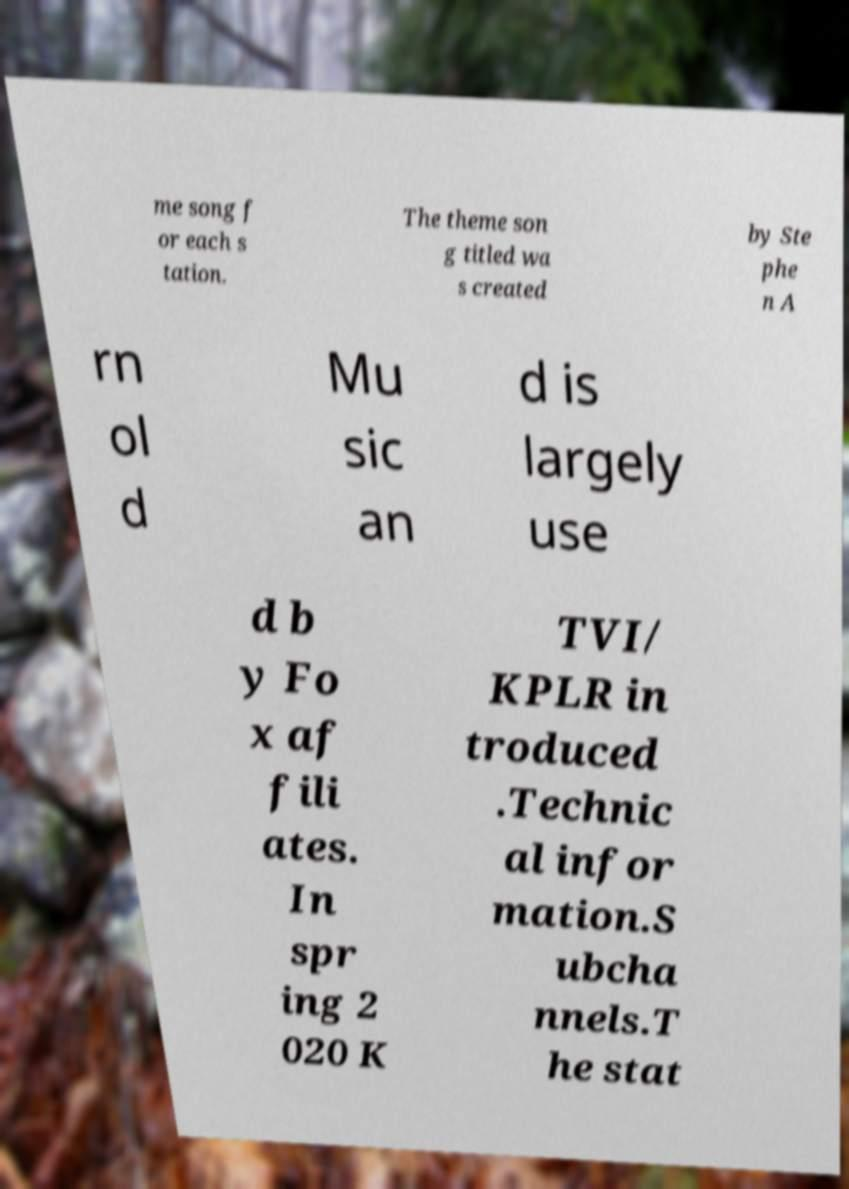Could you assist in decoding the text presented in this image and type it out clearly? me song f or each s tation. The theme son g titled wa s created by Ste phe n A rn ol d Mu sic an d is largely use d b y Fo x af fili ates. In spr ing 2 020 K TVI/ KPLR in troduced .Technic al infor mation.S ubcha nnels.T he stat 